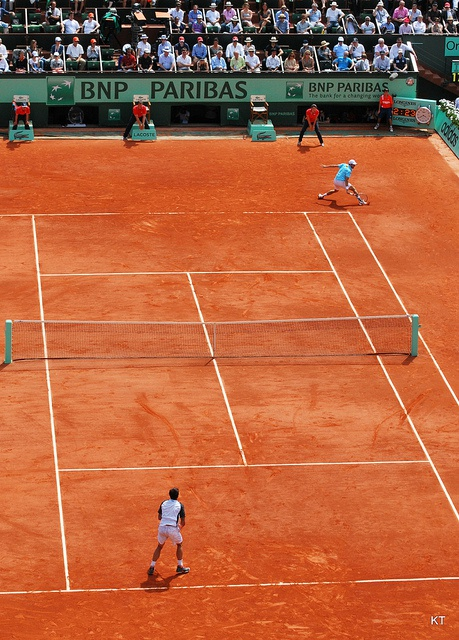Describe the objects in this image and their specific colors. I can see people in black, darkgray, and maroon tones, people in black, gray, darkgray, and maroon tones, people in black, red, maroon, brown, and salmon tones, chair in black, maroon, darkgray, and lightgray tones, and people in black, brown, maroon, and gray tones in this image. 